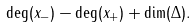<formula> <loc_0><loc_0><loc_500><loc_500>\deg ( x _ { - } ) - \deg ( x _ { + } ) + \dim ( \Delta ) .</formula> 